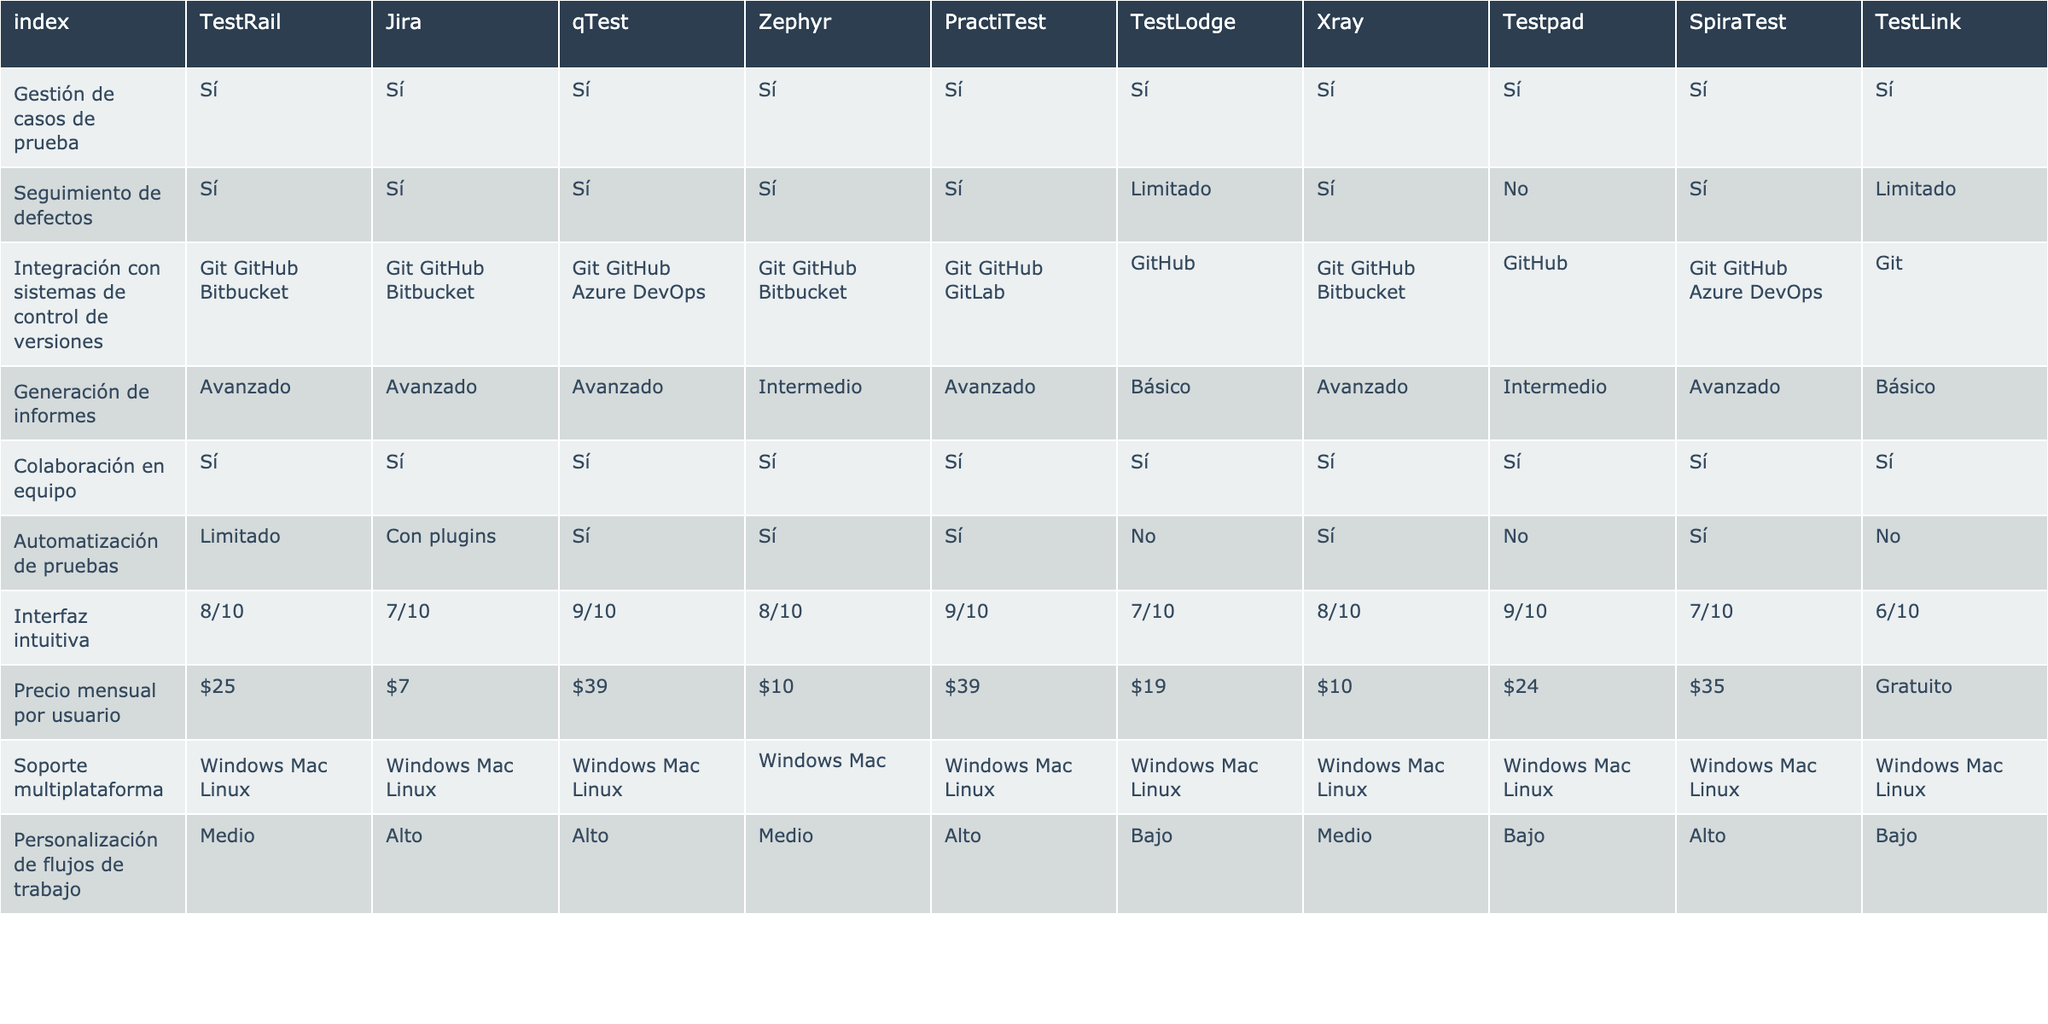¿Cuáles herramientas tienen la capacidad de seguimiento de defectos? Mirando la tabla, las herramientas que tienen "Sí" en la columna de "Seguimiento de defectos" son TestRail, Jira, qTest, Zephyr, PractiTest, SpiraTest y Xray.
Answer: TestRail, Jira, qTest, Zephyr, PractiTest, SpiraTest, Xray ¿Cuál es el precio mensual por usuario más bajo entre las herramientas listadas? Revisando la columna "Precio mensual por usuario", se puede ver que el precio más bajo es $7 que corresponde a la herramienta Jira.
Answer: $7 ¿Cuántas herramientas ofrecen integración con sistemas de control de versiones? Se cuentan las herramientas que tienen "Sí" en la columna "Integración con sistemas de control de versiones". Las herramientas son TestRail, Jira, qTest, Zephyr, PractiTest, TestLodge, Xray y SpiraTest, sumando un total de 8 herramientas.
Answer: 8 ¿Qué herramienta tiene la mejor calificación para la interfaz intuitiva? Se debe comparar las calificaciones en la columna "Interfaz intuitiva". qTest y PractiTest tienen la calificación más alta de 9/10.
Answer: qTest y PractiTest Si se quiere automatizar pruebas, ¿cuáles herramientas son limitadas en esta funcionalidad? Para responder, se revisan las herramientas con "Limitado" en la columna "Automatización de pruebas", que son TestRail y TestLodge.
Answer: TestRail, TestLodge ¿Qué herramientas tienen un precio mensual por usuario superior a $30 y ofrecen generación de informes avanzado? Se necesita ver las herramientas con un precio mensual superior a $30 en la columna "Precio mensual por usuario" que también tienen "Avanzado" en la columna "Generación de informes". Esto incluye qTest, PractiTest y SpiraTest.
Answer: qTest, PractiTest, SpiraTest ¿Cuál es la herramienta más cara y cómo se compara con la más económica? Para esto, se busca el precio más alto y más bajo en la columna "Precio mensual por usuario". qTest y PractiTest son las más caras a $39, mientras que la más económica es Jira a $7. La diferencia es de $32.
Answer: $39 (qTest/PractiTest), $7 (Jira), $32 ¿Cuántas herramientas tienen soporte multiplataforma y ofrecen personalización de flujos de trabajo alta? Se cuentan las herramientas que tienen "Sí" en la columna "Soporte multiplataforma" y "Alto" en "Personalización de flujos de trabajo". Las herramientas que cumplen con esto son Jira, qTest, PractiTest y SpiraTest. Esto suma un total de 4 herramientas.
Answer: 4 